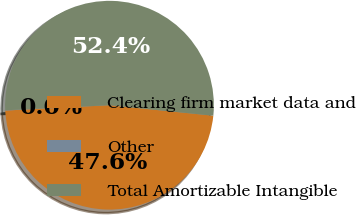Convert chart. <chart><loc_0><loc_0><loc_500><loc_500><pie_chart><fcel>Clearing firm market data and<fcel>Other<fcel>Total Amortizable Intangible<nl><fcel>47.58%<fcel>0.04%<fcel>52.38%<nl></chart> 